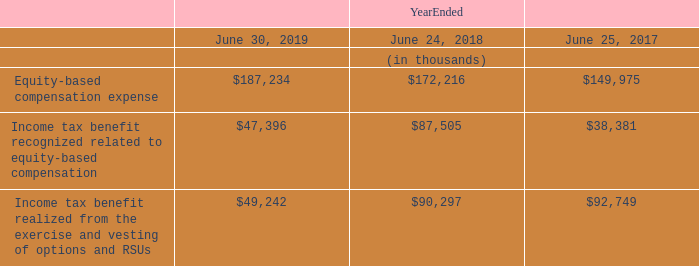Note 5: Equity-based Compensation Plans
The Company has stock plans that provide for grants of equity-based awards to eligible participants, including stock options and restricted stock units, of the Company’s Common Stock. An option is a right to purchase Common Stock at a set price. An RSU award is an agreement to issue a set number of shares of Common Stock at the time of vesting. The Company’s options and RSU awards typically vest over a period of three years or less. The Company also has an employee stock purchase plan that allows employees to purchase its Common Stock at a discount through payroll deductions.
The Lam Research Corporation 2007 Stock Incentive Plan, as amended and restated, 2011 Stock Incentive Plan, as amended and restated, and the 2015 Stock Incentive Plan (collectively the “Stock Plans”), provide for the grant of non-qualified equity-based awards to eligible employees, consultants and advisors, and non-employee directors of the Company and its subsidiaries. The 2015 Stock Incentive Plan was approved by shareholders authorizing up to 18,000,000 shares available for issuance under the plan. Additionally, 1,232,068 shares that remained available for grants under the Company’s 2007 Stock Incentive Plan were added to the shares available for issuance under the 2015 Stock Incentive Plan. As of June 30, 2019, there were a total of 9,379,904 shares available for future issuance under the Stock Plans. New shares are issued from the Company’s balance of authorized Common Stock from the 2015 Stock Incentive Plan to satisfy stock option exercises and vesting of awards.
The Company recognized the following equity-based compensation expense and benefits in the Consolidated Statements of Operations:
The estimated fair value of the Company’s equity-based awards, less expected forfeitures, is amortized over the awards’ vesting terms on a straight-line basis.
What is the employee stock purchase plan? Allows employees to purchase its common stock at a discount through payroll deductions. How many shares were authorised for issuance under the 2015 Stock Incentive Plan? Up to 18,000,000 shares. What is the total number of shares available for future issuance under the Stock Plans as of June 30, 2019? 9,379,904 shares. What is the percentage change in the Equity-based compensation expense from 2018 to 2019?
Answer scale should be: percent. (187,234-172,216)/172,216
Answer: 8.72. What is the percentage change in the Income tax benefit recognized related to equity-based compensation from 2018 to 2019?
Answer scale should be: percent. (47,396-87,505)/87,505
Answer: -45.84. What is the percentage change in the Income tax benefit realized from the exercise and vesting of options and RSUs from 2018 to 2019?
Answer scale should be: percent. (49,242-90,297)/90,297
Answer: -45.47. 